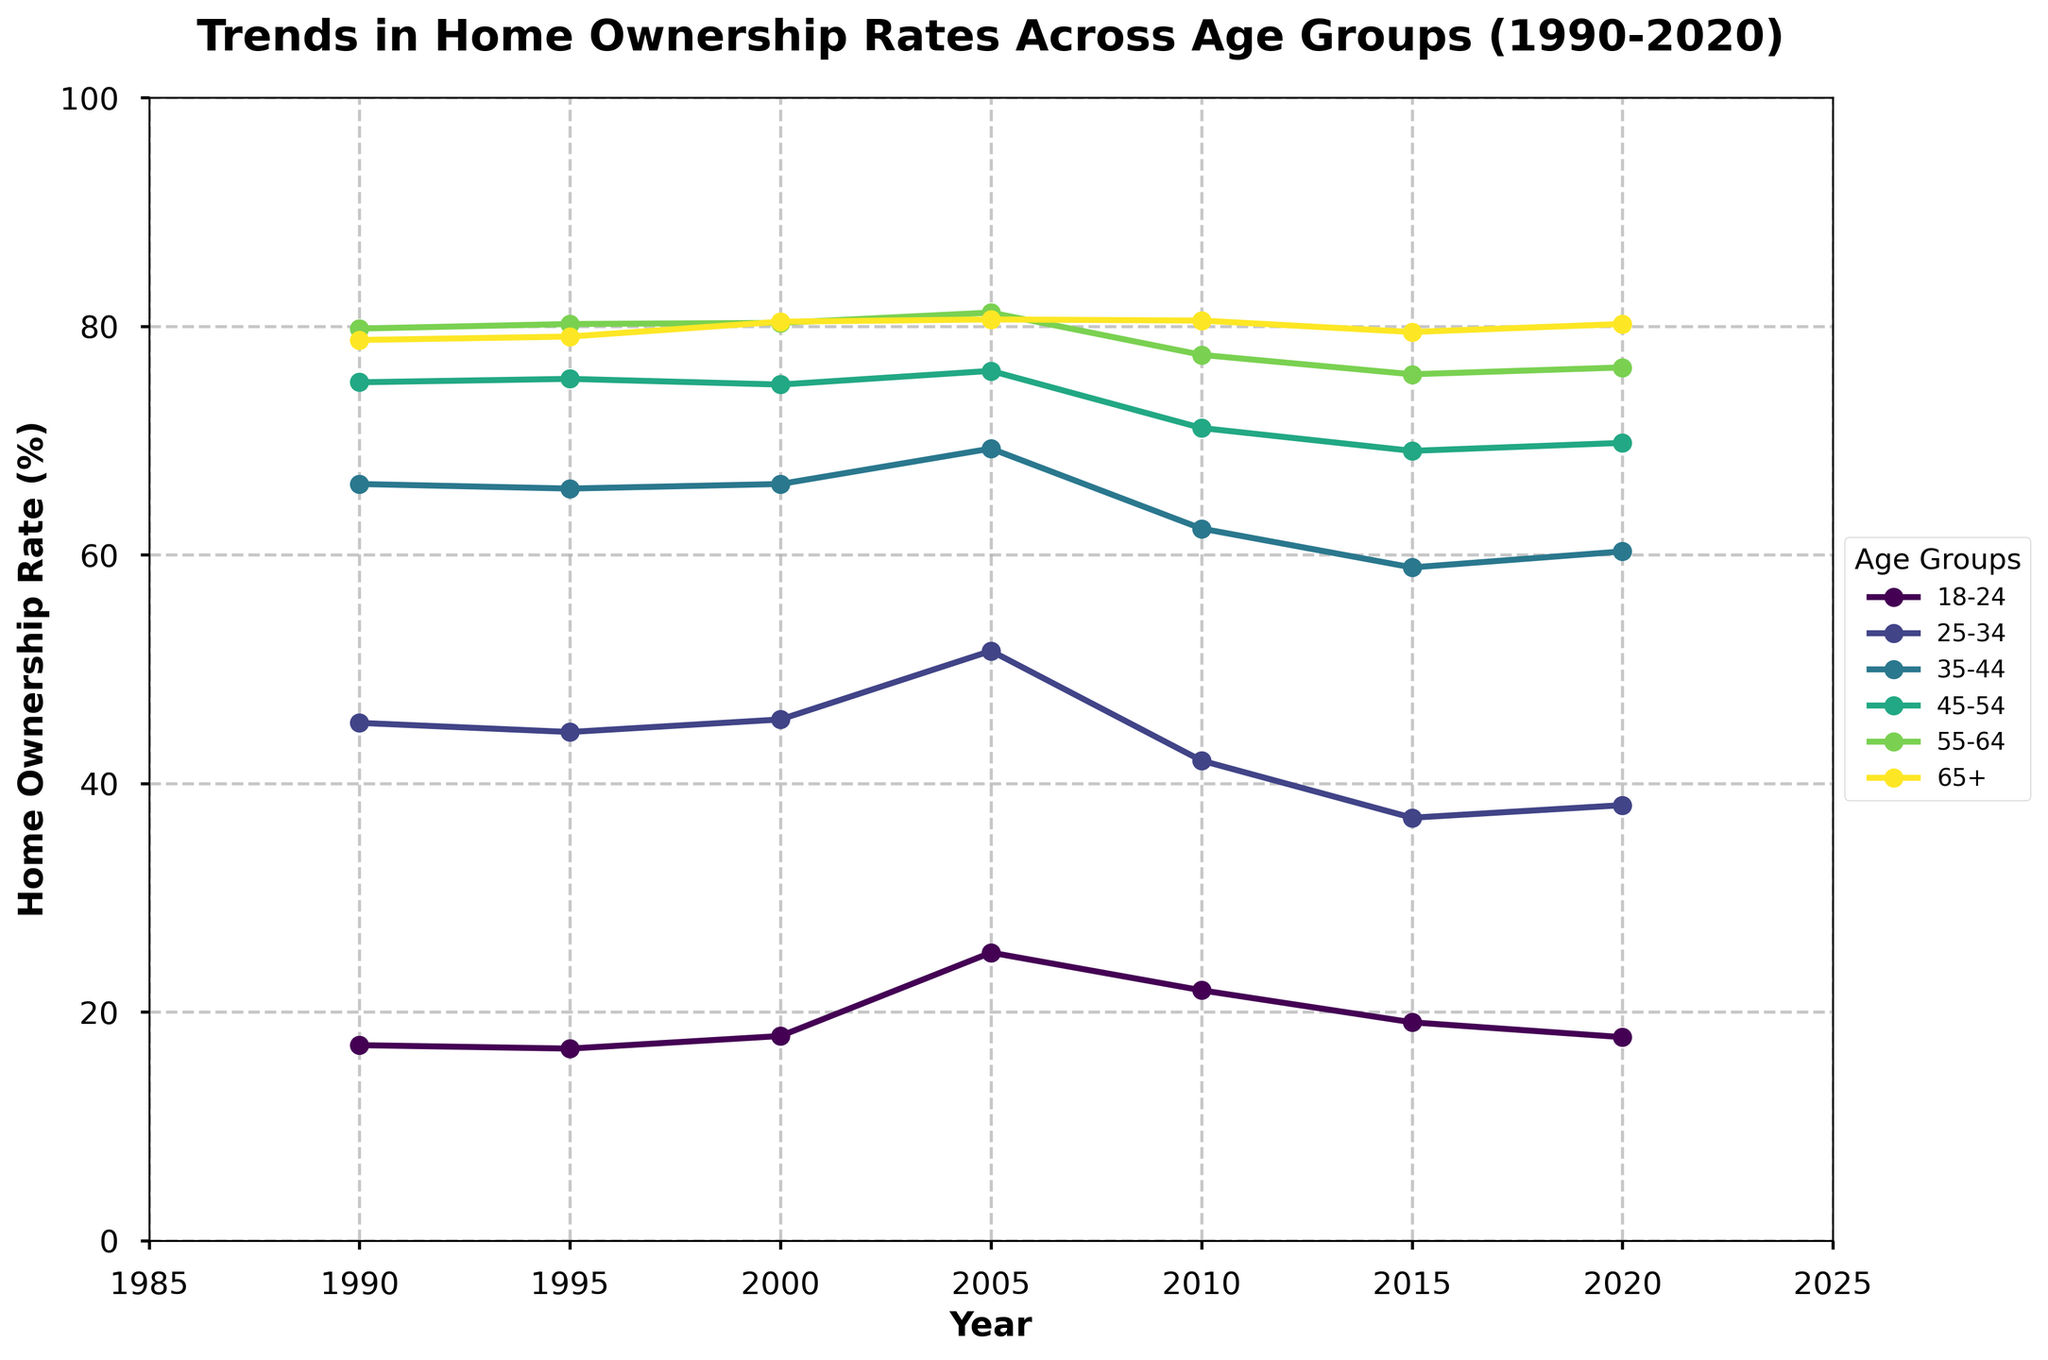What was the home ownership rate for the 18-24 age group in 2020? Locate the line representing the 18-24 age group and follow it to the 2020 marker on the x-axis. The y-axis value is approximately 17.8.
Answer: 17.8 Which age group had the highest home ownership rate in 2000? Locate the year 2000 on the x-axis and compare the y-axis values for all age groups. The 65+ group had the highest rate at around 80.4.
Answer: 65+ By how many percentage points did the home ownership rate for the 25-34 age group change from 1995 to 2015? Identify the home ownership rates for 25-34 in 1995 (44.5%) and 2015 (37.0%). The change is 44.5 - 37.0 = 7.5 percentage points.
Answer: 7.5 What is the overall trend in home ownership rates for the 45-54 age group over the 30-year period? Observe the line representing the 45-54 age group from 1990 to 2020. The rate starts high at 75.1% in 1990 and generally declines to about 69.8% in 2020, indicating a downward trend.
Answer: Downward Which age group showed the most variability in home ownership rates over the 30-year span? Compare the fluctuations in the lines for all age groups from 1990 to 2020. The 25-34 age group showed the most change, with a rise to about 51.6% in 2005 and a drop to around 37.0% in 2015.
Answer: 25-34 In which year did the home ownership rate for the 35-44 age group peak? Observe the line representing the 35-44 age group and identify the year with the highest y-axis value. The peak occurs in 2005 at 69.3%.
Answer: 2005 Between 2010 and 2020, which age group saw an increase in home ownership rates? Compare the values for each age group for the years 2010 and 2020. The 25-34 (from 42.0% to 38.1%) and 35-44 age groups (from 62.3% to 60.3%) actually saw decreases, while the 18-24 (from 21.9% to 17.8%), 45-54 (from 71.1% to 69.8%), 55-64 (from 77.5% to 76.4%), and 65+ (from 80.5% to 80.2%) had negligible changes or decreases, indicating no substantial increase for any group.
Answer: None Calculate the average home ownership rate for the 55-64 age group across all years. Add the rates for the 55-64 age group for all years and divide by the number of years: (79.8 + 80.2 + 80.3 + 81.2 + 77.5 + 75.8 + 76.4) / 7 = 78.89.
Answer: 78.89 